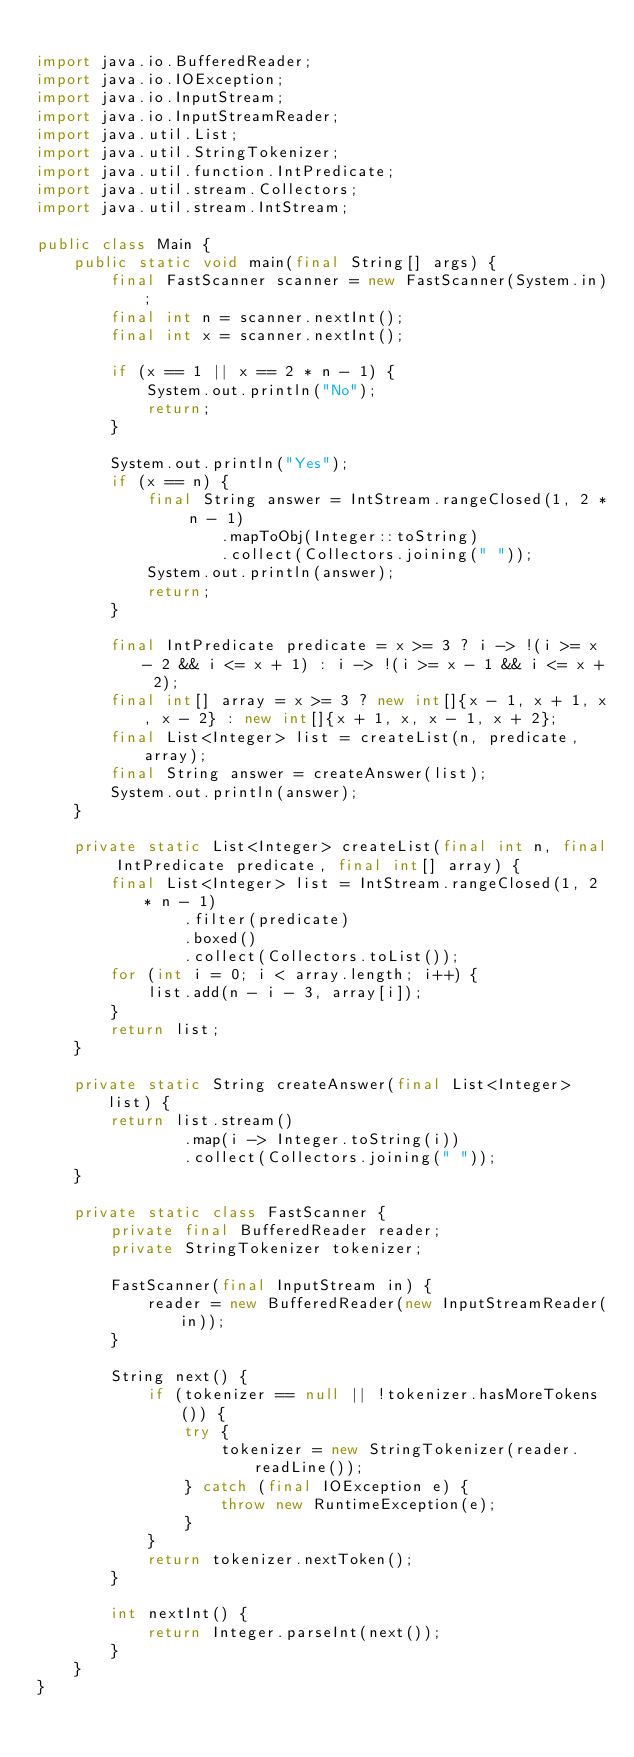<code> <loc_0><loc_0><loc_500><loc_500><_Java_>
import java.io.BufferedReader;
import java.io.IOException;
import java.io.InputStream;
import java.io.InputStreamReader;
import java.util.List;
import java.util.StringTokenizer;
import java.util.function.IntPredicate;
import java.util.stream.Collectors;
import java.util.stream.IntStream;

public class Main {
    public static void main(final String[] args) {
        final FastScanner scanner = new FastScanner(System.in);
        final int n = scanner.nextInt();
        final int x = scanner.nextInt();

        if (x == 1 || x == 2 * n - 1) {
            System.out.println("No");
            return;
        }

        System.out.println("Yes");
        if (x == n) {
            final String answer = IntStream.rangeClosed(1, 2 * n - 1)
                    .mapToObj(Integer::toString)
                    .collect(Collectors.joining(" "));
            System.out.println(answer);
            return;
        }

        final IntPredicate predicate = x >= 3 ? i -> !(i >= x - 2 && i <= x + 1) : i -> !(i >= x - 1 && i <= x + 2);
        final int[] array = x >= 3 ? new int[]{x - 1, x + 1, x, x - 2} : new int[]{x + 1, x, x - 1, x + 2};
        final List<Integer> list = createList(n, predicate, array);
        final String answer = createAnswer(list);
        System.out.println(answer);
    }

    private static List<Integer> createList(final int n, final IntPredicate predicate, final int[] array) {
        final List<Integer> list = IntStream.rangeClosed(1, 2 * n - 1)
                .filter(predicate)
                .boxed()
                .collect(Collectors.toList());
        for (int i = 0; i < array.length; i++) {
            list.add(n - i - 3, array[i]);
        }
        return list;
    }

    private static String createAnswer(final List<Integer> list) {
        return list.stream()
                .map(i -> Integer.toString(i))
                .collect(Collectors.joining(" "));
    }

    private static class FastScanner {
        private final BufferedReader reader;
        private StringTokenizer tokenizer;

        FastScanner(final InputStream in) {
            reader = new BufferedReader(new InputStreamReader(in));
        }

        String next() {
            if (tokenizer == null || !tokenizer.hasMoreTokens()) {
                try {
                    tokenizer = new StringTokenizer(reader.readLine());
                } catch (final IOException e) {
                    throw new RuntimeException(e);
                }
            }
            return tokenizer.nextToken();
        }

        int nextInt() {
            return Integer.parseInt(next());
        }
    }
}
</code> 